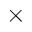<formula> <loc_0><loc_0><loc_500><loc_500>\times</formula> 